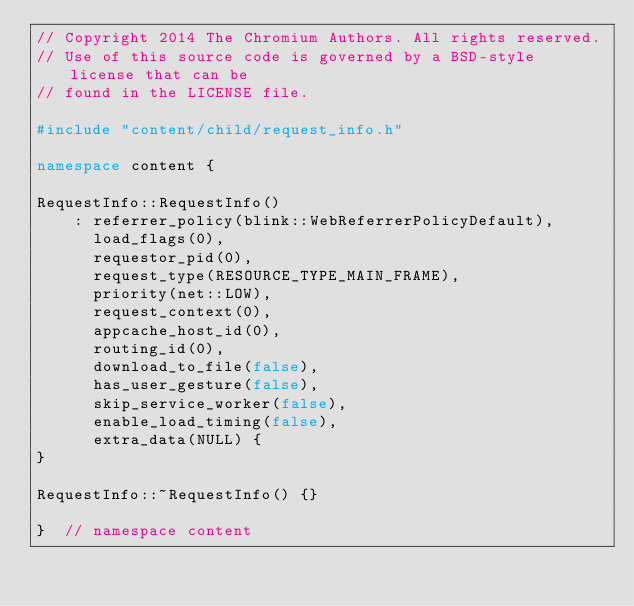Convert code to text. <code><loc_0><loc_0><loc_500><loc_500><_C++_>// Copyright 2014 The Chromium Authors. All rights reserved.
// Use of this source code is governed by a BSD-style license that can be
// found in the LICENSE file.

#include "content/child/request_info.h"

namespace content {

RequestInfo::RequestInfo()
    : referrer_policy(blink::WebReferrerPolicyDefault),
      load_flags(0),
      requestor_pid(0),
      request_type(RESOURCE_TYPE_MAIN_FRAME),
      priority(net::LOW),
      request_context(0),
      appcache_host_id(0),
      routing_id(0),
      download_to_file(false),
      has_user_gesture(false),
      skip_service_worker(false),
      enable_load_timing(false),
      extra_data(NULL) {
}

RequestInfo::~RequestInfo() {}

}  // namespace content
</code> 